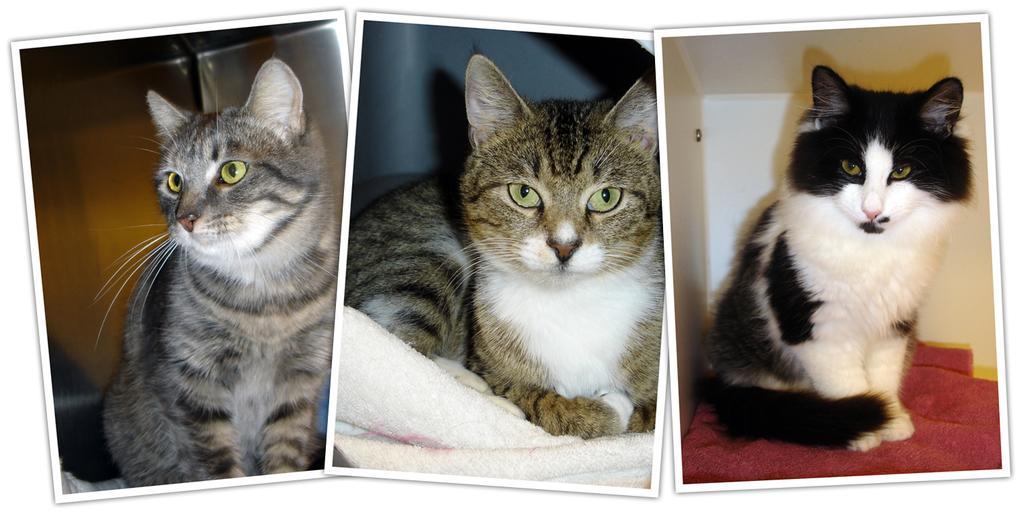Please provide a concise description of this image. This is an edited collage image , where there are three cats on the napkins. 